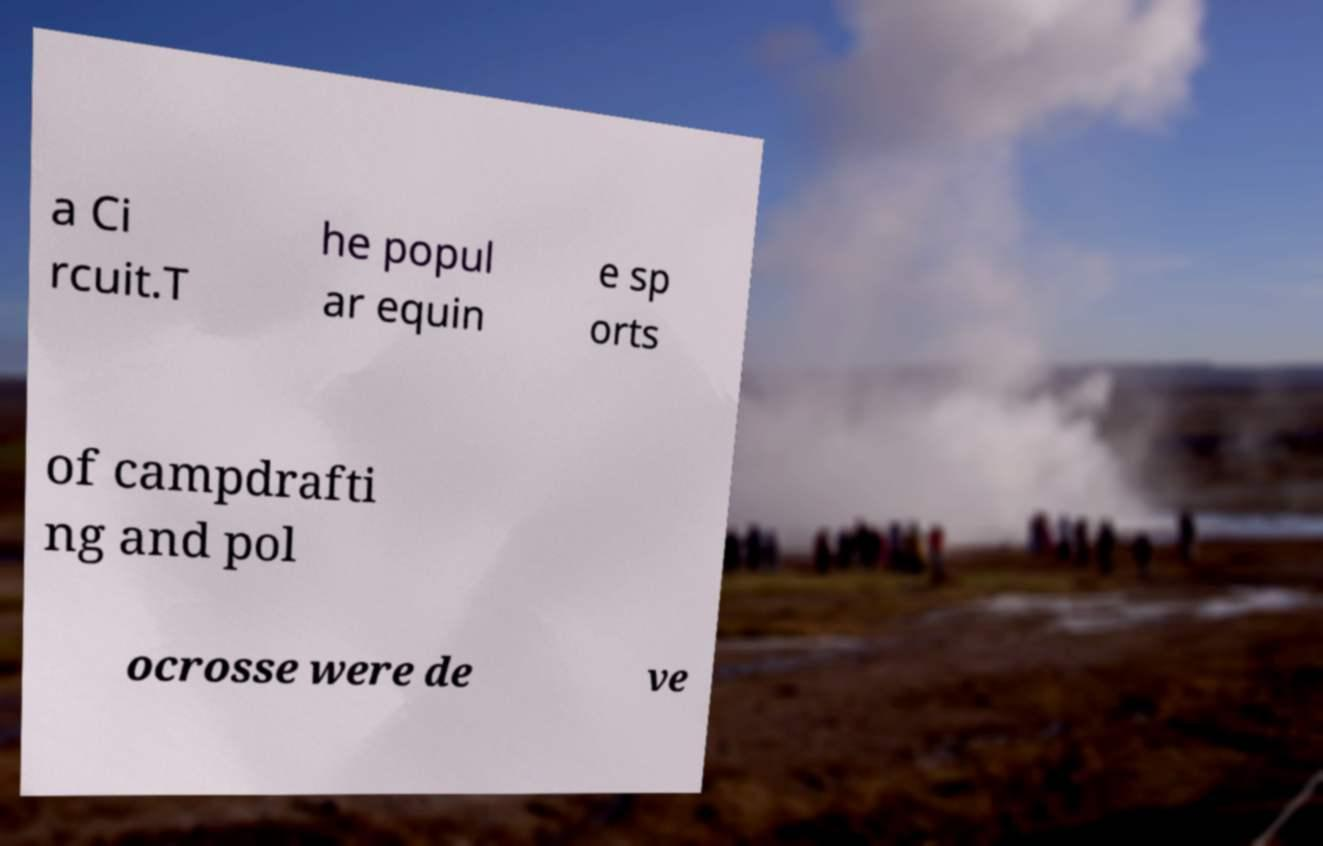Can you accurately transcribe the text from the provided image for me? a Ci rcuit.T he popul ar equin e sp orts of campdrafti ng and pol ocrosse were de ve 